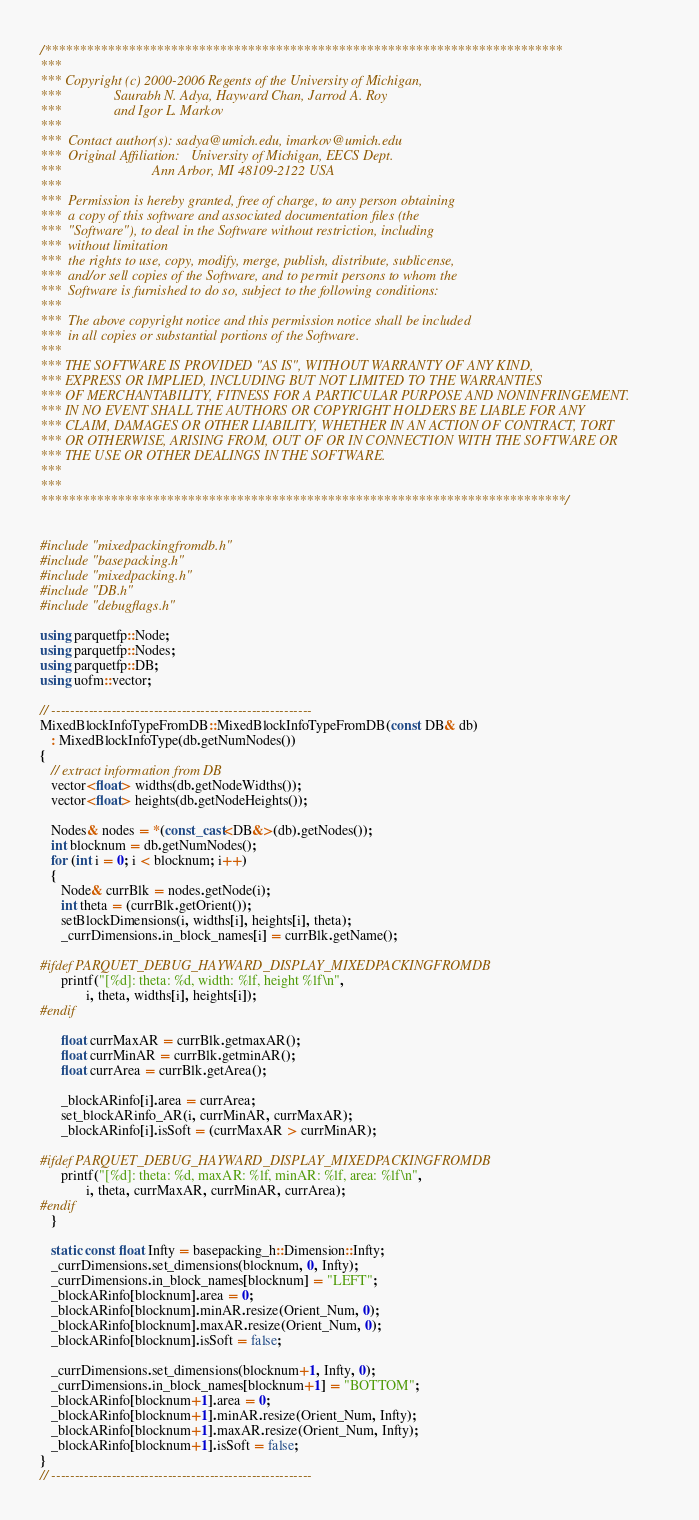<code> <loc_0><loc_0><loc_500><loc_500><_C++_>/**************************************************************************
***    
*** Copyright (c) 2000-2006 Regents of the University of Michigan,
***               Saurabh N. Adya, Hayward Chan, Jarrod A. Roy
***               and Igor L. Markov
***
***  Contact author(s): sadya@umich.edu, imarkov@umich.edu
***  Original Affiliation:   University of Michigan, EECS Dept.
***                          Ann Arbor, MI 48109-2122 USA
***
***  Permission is hereby granted, free of charge, to any person obtaining 
***  a copy of this software and associated documentation files (the
***  "Software"), to deal in the Software without restriction, including
***  without limitation 
***  the rights to use, copy, modify, merge, publish, distribute, sublicense, 
***  and/or sell copies of the Software, and to permit persons to whom the 
***  Software is furnished to do so, subject to the following conditions:
***
***  The above copyright notice and this permission notice shall be included
***  in all copies or substantial portions of the Software.
***
*** THE SOFTWARE IS PROVIDED "AS IS", WITHOUT WARRANTY OF ANY KIND, 
*** EXPRESS OR IMPLIED, INCLUDING BUT NOT LIMITED TO THE WARRANTIES
*** OF MERCHANTABILITY, FITNESS FOR A PARTICULAR PURPOSE AND NONINFRINGEMENT. 
*** IN NO EVENT SHALL THE AUTHORS OR COPYRIGHT HOLDERS BE LIABLE FOR ANY
*** CLAIM, DAMAGES OR OTHER LIABILITY, WHETHER IN AN ACTION OF CONTRACT, TORT
*** OR OTHERWISE, ARISING FROM, OUT OF OR IN CONNECTION WITH THE SOFTWARE OR
*** THE USE OR OTHER DEALINGS IN THE SOFTWARE.
***
***
***************************************************************************/


#include "mixedpackingfromdb.h"
#include "basepacking.h"
#include "mixedpacking.h"
#include "DB.h"
#include "debugflags.h"

using parquetfp::Node;
using parquetfp::Nodes;
using parquetfp::DB;
using uofm::vector;

// --------------------------------------------------------
MixedBlockInfoTypeFromDB::MixedBlockInfoTypeFromDB(const DB& db)
   : MixedBlockInfoType(db.getNumNodes())
{
   // extract information from DB
   vector<float> widths(db.getNodeWidths());
   vector<float> heights(db.getNodeHeights());

   Nodes& nodes = *(const_cast<DB&>(db).getNodes());
   int blocknum = db.getNumNodes();
   for (int i = 0; i < blocknum; i++)
   {
      Node& currBlk = nodes.getNode(i);
      int theta = (currBlk.getOrient());
      setBlockDimensions(i, widths[i], heights[i], theta);
      _currDimensions.in_block_names[i] = currBlk.getName();

#ifdef PARQUET_DEBUG_HAYWARD_DISPLAY_MIXEDPACKINGFROMDB
      printf("[%d]: theta: %d, width: %lf, height %lf\n",
             i, theta, widths[i], heights[i]);
#endif
      
      float currMaxAR = currBlk.getmaxAR();
      float currMinAR = currBlk.getminAR();
      float currArea = currBlk.getArea();

      _blockARinfo[i].area = currArea;
      set_blockARinfo_AR(i, currMinAR, currMaxAR);
      _blockARinfo[i].isSoft = (currMaxAR > currMinAR);

#ifdef PARQUET_DEBUG_HAYWARD_DISPLAY_MIXEDPACKINGFROMDB
      printf("[%d]: theta: %d, maxAR: %lf, minAR: %lf, area: %lf\n",
             i, theta, currMaxAR, currMinAR, currArea);
#endif
   }

   static const float Infty = basepacking_h::Dimension::Infty;   
   _currDimensions.set_dimensions(blocknum, 0, Infty);
   _currDimensions.in_block_names[blocknum] = "LEFT";
   _blockARinfo[blocknum].area = 0;
   _blockARinfo[blocknum].minAR.resize(Orient_Num, 0);
   _blockARinfo[blocknum].maxAR.resize(Orient_Num, 0);
   _blockARinfo[blocknum].isSoft = false;

   _currDimensions.set_dimensions(blocknum+1, Infty, 0);
   _currDimensions.in_block_names[blocknum+1] = "BOTTOM";
   _blockARinfo[blocknum+1].area = 0;
   _blockARinfo[blocknum+1].minAR.resize(Orient_Num, Infty);
   _blockARinfo[blocknum+1].maxAR.resize(Orient_Num, Infty);
   _blockARinfo[blocknum+1].isSoft = false;
}
// --------------------------------------------------------

</code> 